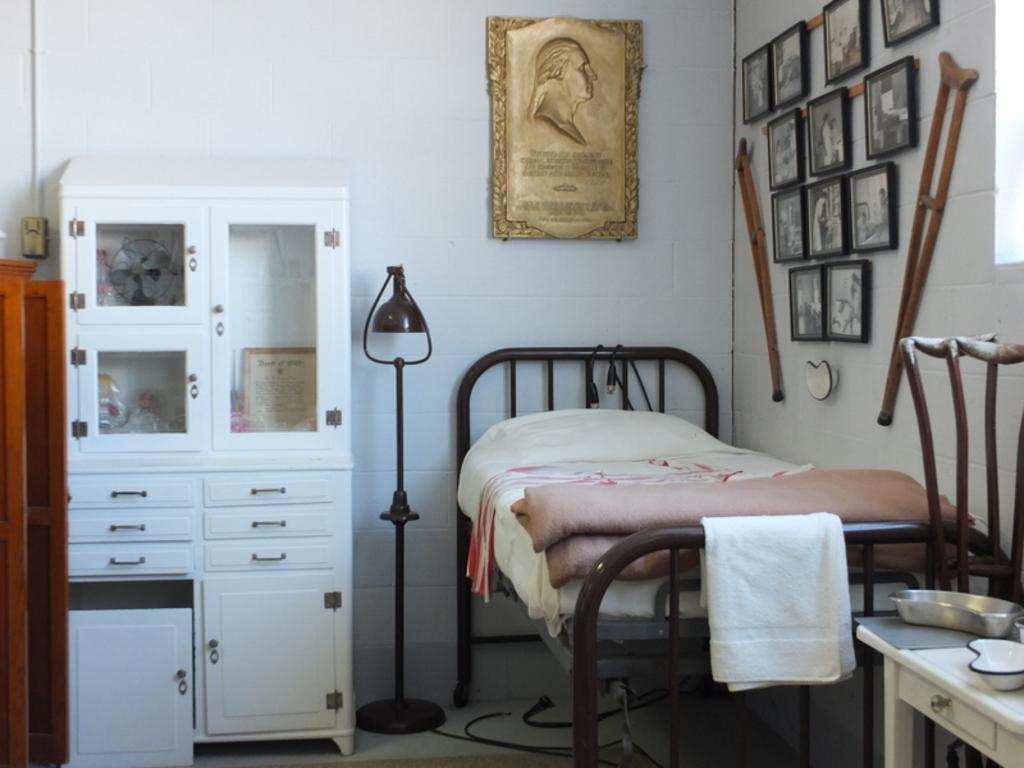Please provide a concise description of this image. This is the picture inside the room. There is a bed at the left there is a cupboard. On the wall there are photo frames and there is a desk, there are bowls on the desk. At the bottom there are wires and there is a light between the bad and the cupboard. 